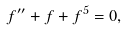<formula> <loc_0><loc_0><loc_500><loc_500>f ^ { \prime \prime } + f + f ^ { 5 } = 0 ,</formula> 